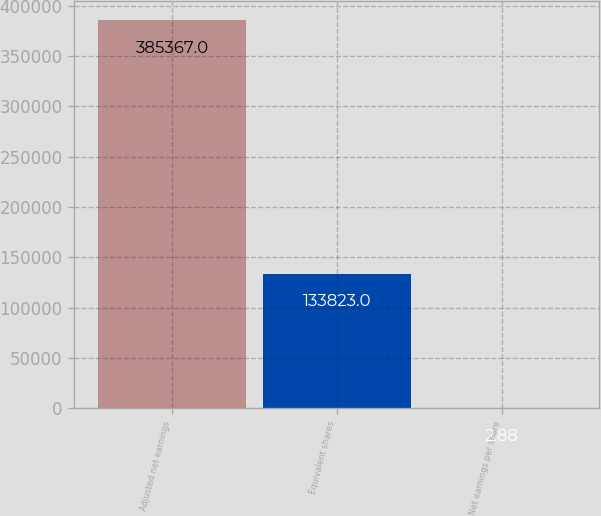Convert chart. <chart><loc_0><loc_0><loc_500><loc_500><bar_chart><fcel>Adjusted net earnings<fcel>Equivalent shares<fcel>Net earnings per share<nl><fcel>385367<fcel>133823<fcel>2.88<nl></chart> 